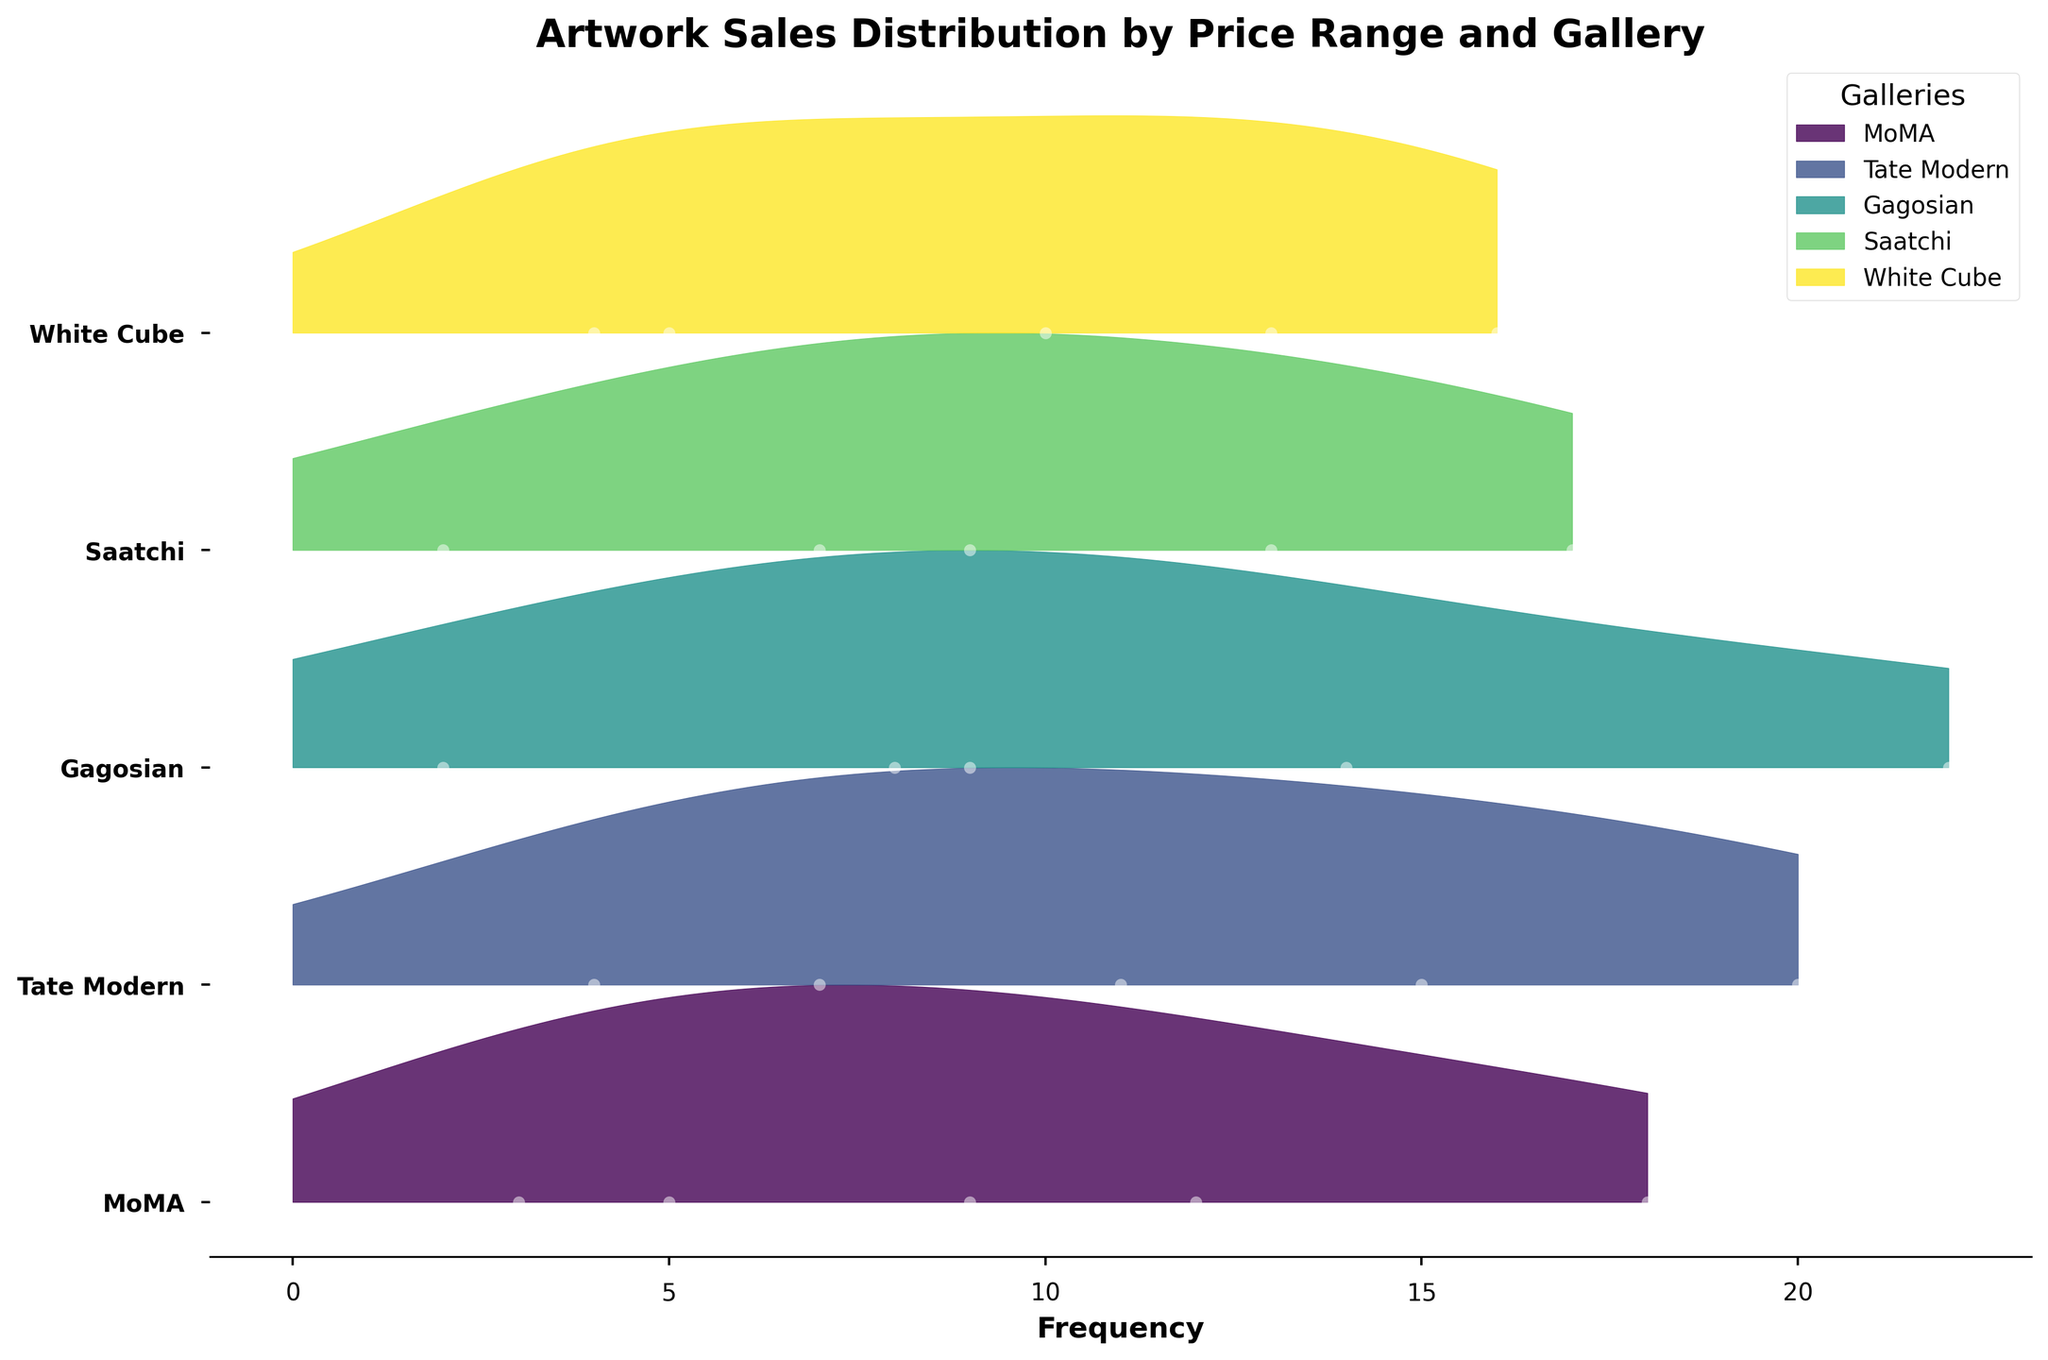What is the title of the plot? The title is prominently displayed at the top of the plot. It summarizes the main content and purpose of the plot, indicating the type of data shown.
Answer: Artwork Sales Distribution by Price Range and Gallery How many galleries are included in the plot? The y-axis labels represent the different galleries included in the plot. Counting these labels will give the number of galleries.
Answer: 5 Which gallery has the highest frequency of sales in the "$10001-$50000" price range? The plot fills between values and y-axis points to create Ridgeline plots for each gallery. Identifying the gallery with the highest peak in the "$10001-$50000" range shows the answer.
Answer: Gagosian What is the price range with the most frequent sales at Tate Modern? The plot's filled areas and peaks indicate the frequency of sales for each price range. The highest peak corresponding to Tate Modern shows the price range with the most sales.
Answer: $5001-$10000 How does the sales frequency in the "$0-$1000" price range at White Cube compare to MoMA? Comparing the heights of the filled areas beneath each gallery for the "$0-$1000" range shows the relative frequency of sales.
Answer: White Cube has fewer sales Which gallery has the most uniform distribution of sales across all price ranges? A uniform distribution means consistent fill heights across all price ranges. Visually inspecting each gallery's plot shows this consistency.
Answer: White Cube If you sum the frequencies of the "$50001+" price range sales for all galleries, what is the total? Summing the frequency values shown along the x-axis for the "$50001+" range across all galleries provides the total.
Answer: 23 What can you infer about Gagosian's sales trends compared to Saatchi? Analyzing each gallery's filled areas and peaks across all price ranges illustrates their sales patterns, including which price ranges have higher frequencies.
Answer: Gagosian has more high-value sales Which price range shows the highest overall frequency of sales across all galleries? Summing the peaks for each price range across all galleries reveals the price range with the highest total sales.
Answer: $5001-$10000 What is the average frequency of sales in the "$1001-$5000" price range across all galleries? Summing the frequencies for the "$1001-$5000" range and dividing by the number of galleries gives the average.
Answer: 12.4 